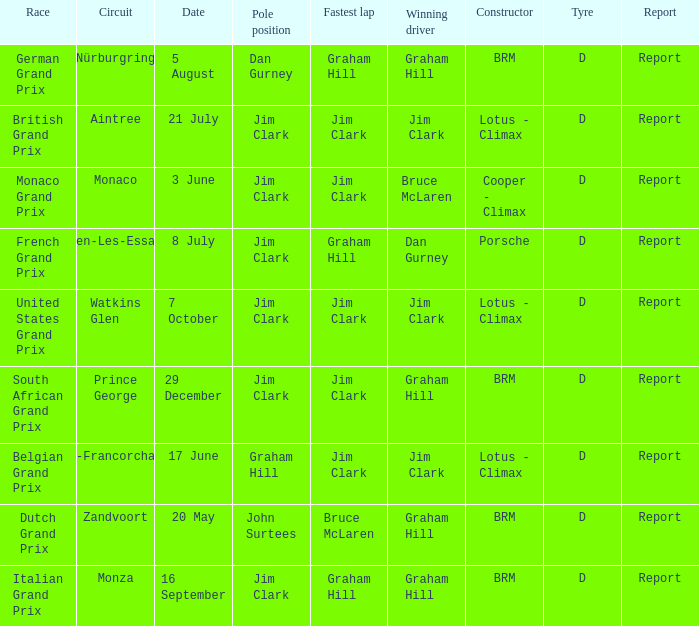What is the date of the circuit of nürburgring, which had Graham Hill as the winning driver? 5 August. 